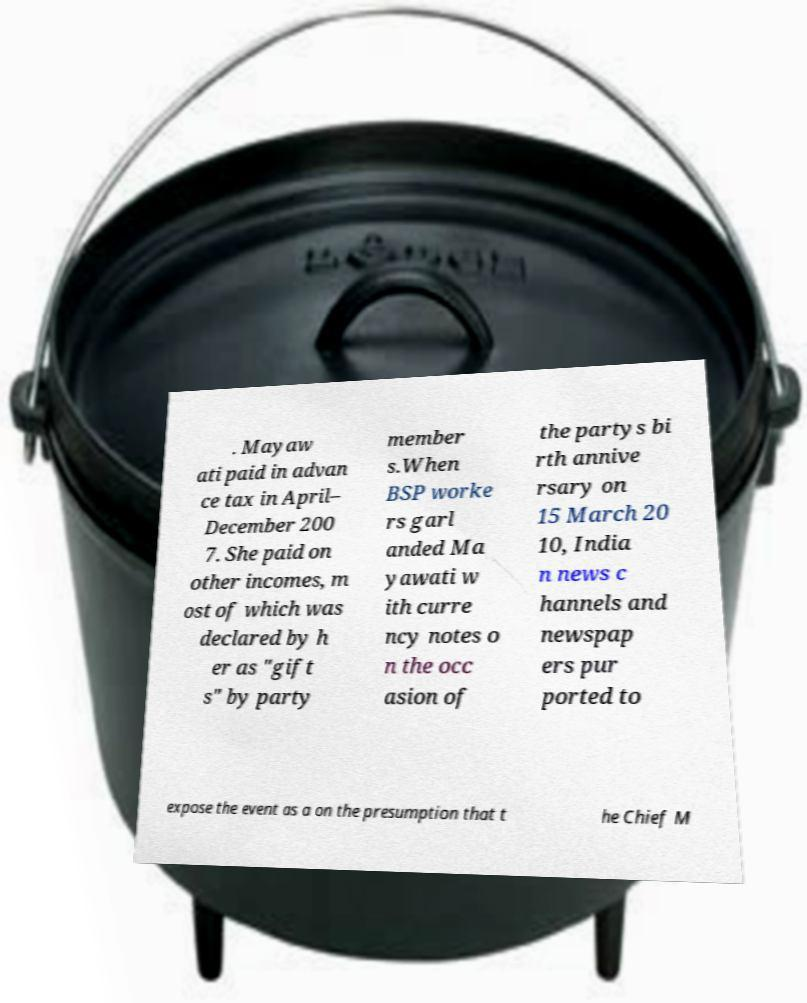Can you accurately transcribe the text from the provided image for me? . Mayaw ati paid in advan ce tax in April– December 200 7. She paid on other incomes, m ost of which was declared by h er as "gift s" by party member s.When BSP worke rs garl anded Ma yawati w ith curre ncy notes o n the occ asion of the partys bi rth annive rsary on 15 March 20 10, India n news c hannels and newspap ers pur ported to expose the event as a on the presumption that t he Chief M 